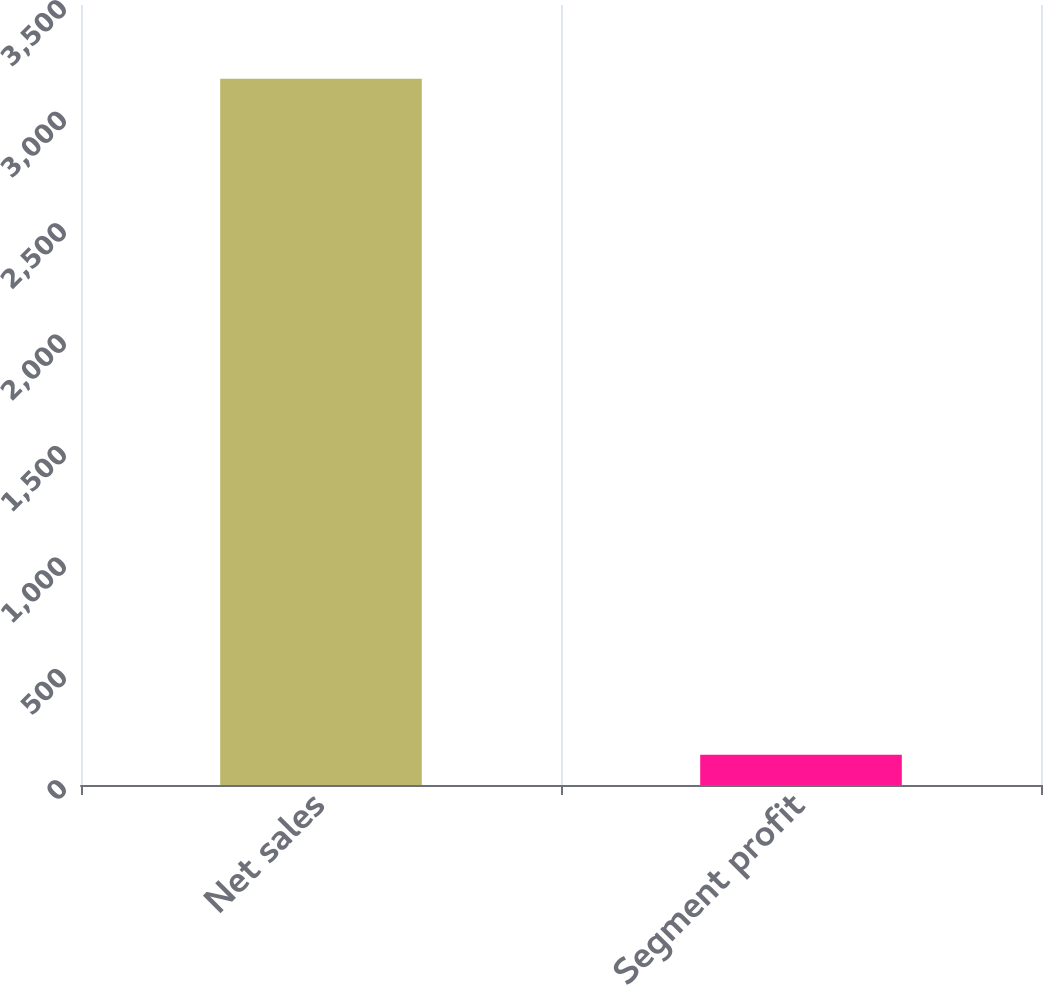Convert chart to OTSL. <chart><loc_0><loc_0><loc_500><loc_500><bar_chart><fcel>Net sales<fcel>Segment profit<nl><fcel>3169<fcel>136<nl></chart> 